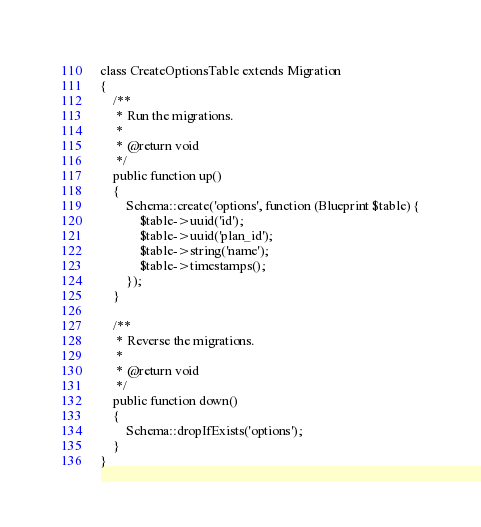Convert code to text. <code><loc_0><loc_0><loc_500><loc_500><_PHP_>class CreateOptionsTable extends Migration
{
    /**
     * Run the migrations.
     *
     * @return void
     */
    public function up()
    {
        Schema::create('options', function (Blueprint $table) {
            $table->uuid('id');
            $table->uuid('plan_id');
            $table->string('name');
            $table->timestamps();
        });
    }

    /**
     * Reverse the migrations.
     *
     * @return void
     */
    public function down()
    {
        Schema::dropIfExists('options');
    }
}
</code> 